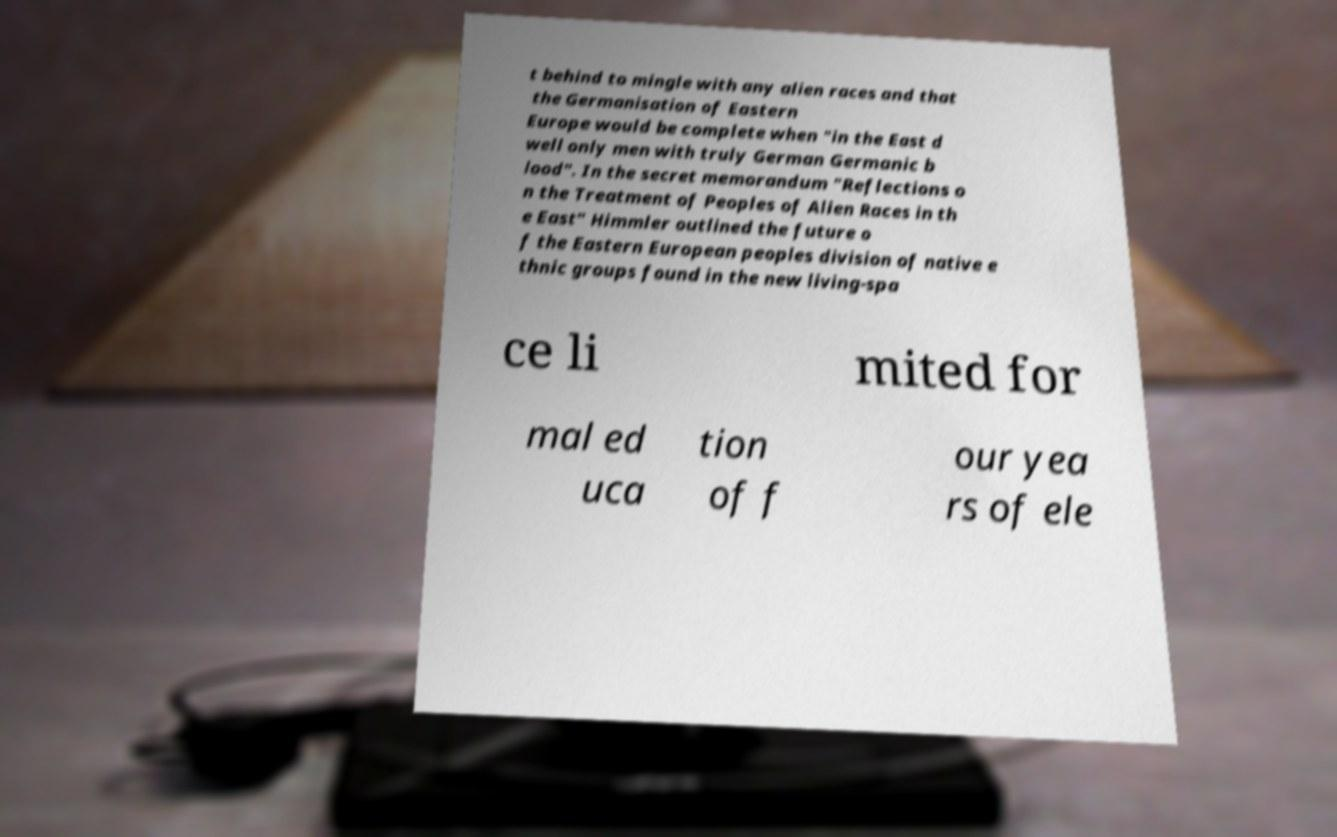Please read and relay the text visible in this image. What does it say? t behind to mingle with any alien races and that the Germanisation of Eastern Europe would be complete when "in the East d well only men with truly German Germanic b lood". In the secret memorandum "Reflections o n the Treatment of Peoples of Alien Races in th e East" Himmler outlined the future o f the Eastern European peoples division of native e thnic groups found in the new living-spa ce li mited for mal ed uca tion of f our yea rs of ele 